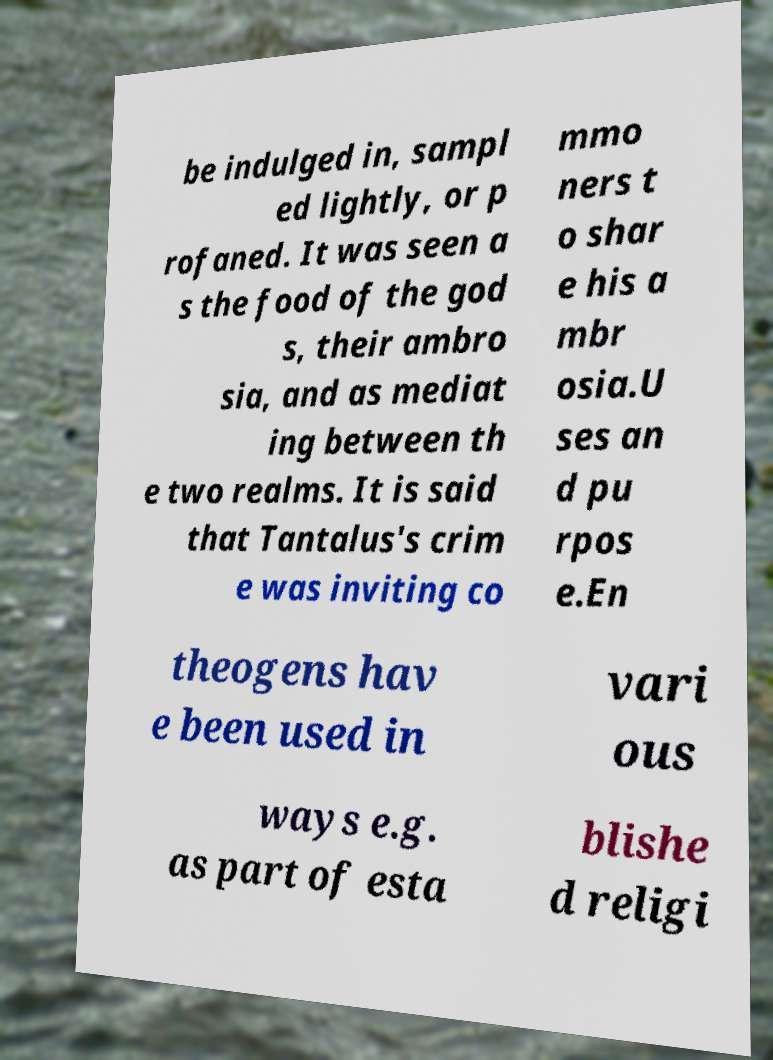For documentation purposes, I need the text within this image transcribed. Could you provide that? be indulged in, sampl ed lightly, or p rofaned. It was seen a s the food of the god s, their ambro sia, and as mediat ing between th e two realms. It is said that Tantalus's crim e was inviting co mmo ners t o shar e his a mbr osia.U ses an d pu rpos e.En theogens hav e been used in vari ous ways e.g. as part of esta blishe d religi 